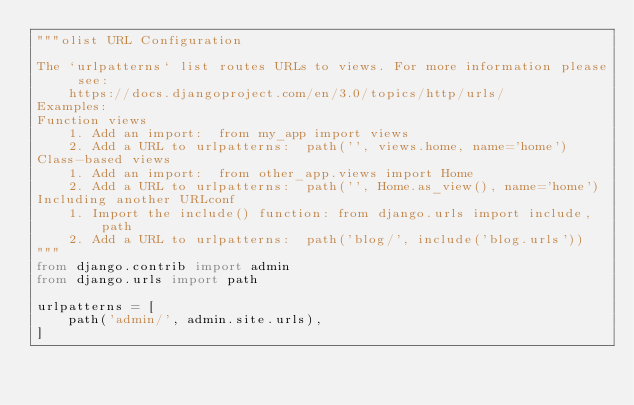Convert code to text. <code><loc_0><loc_0><loc_500><loc_500><_Python_>"""olist URL Configuration

The `urlpatterns` list routes URLs to views. For more information please see:
    https://docs.djangoproject.com/en/3.0/topics/http/urls/
Examples:
Function views
    1. Add an import:  from my_app import views
    2. Add a URL to urlpatterns:  path('', views.home, name='home')
Class-based views
    1. Add an import:  from other_app.views import Home
    2. Add a URL to urlpatterns:  path('', Home.as_view(), name='home')
Including another URLconf
    1. Import the include() function: from django.urls import include, path
    2. Add a URL to urlpatterns:  path('blog/', include('blog.urls'))
"""
from django.contrib import admin
from django.urls import path

urlpatterns = [
    path('admin/', admin.site.urls),
]
</code> 